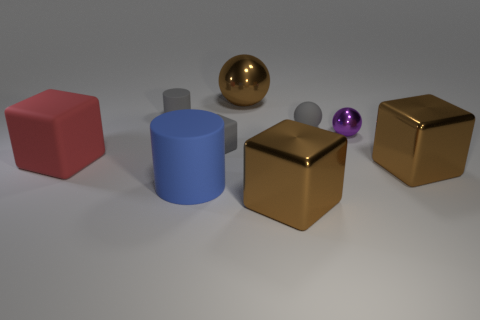Add 1 large cyan matte objects. How many objects exist? 10 Subtract all blocks. How many objects are left? 5 Add 6 cylinders. How many cylinders are left? 8 Add 6 gray cylinders. How many gray cylinders exist? 7 Subtract 1 gray cylinders. How many objects are left? 8 Subtract all gray matte cubes. Subtract all large balls. How many objects are left? 7 